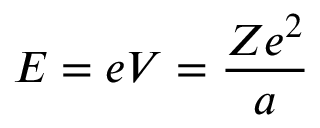Convert formula to latex. <formula><loc_0><loc_0><loc_500><loc_500>E = e V = { \frac { Z e ^ { 2 } } { a } } \,</formula> 